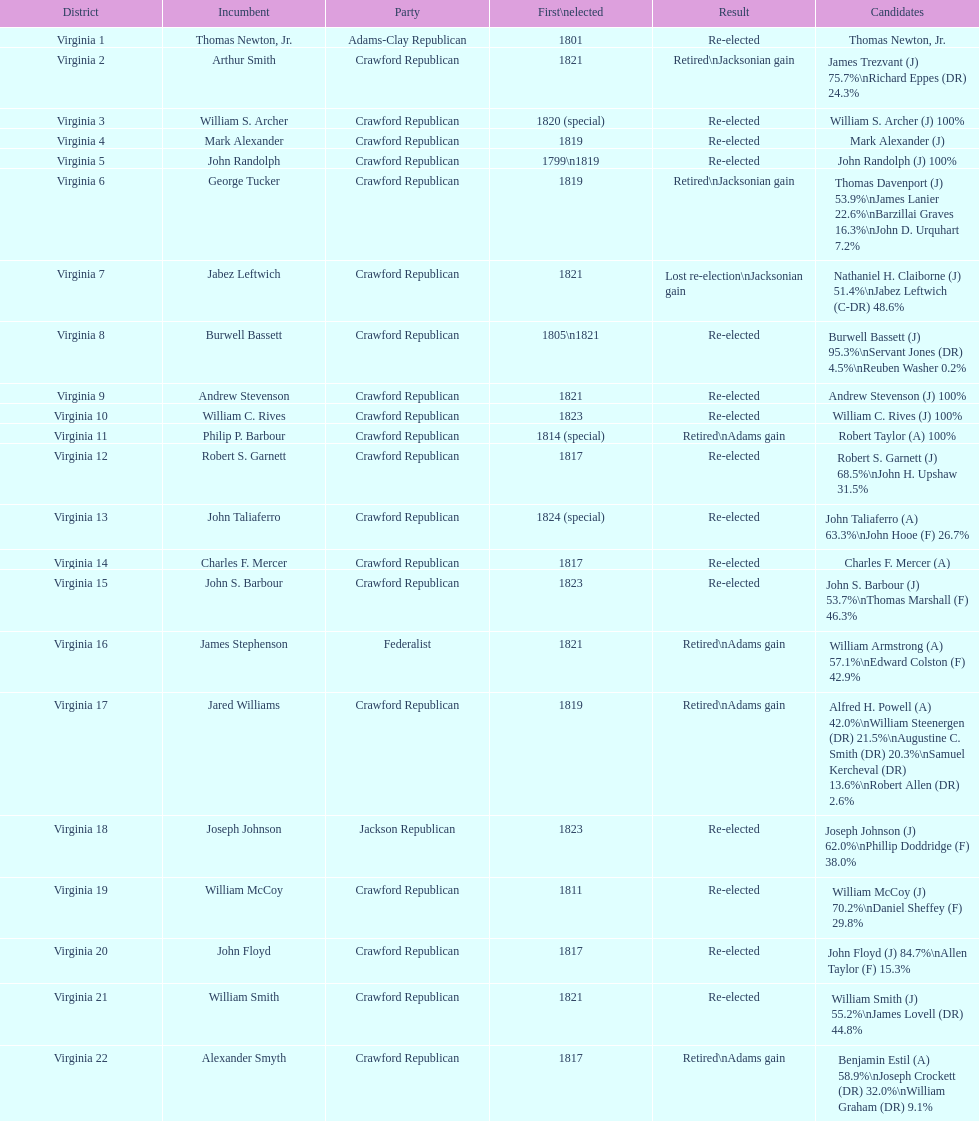Which individuals from the crawford republican party held office? Arthur Smith, William S. Archer, Mark Alexander, John Randolph, George Tucker, Jabez Leftwich, Burwell Bassett, Andrew Stevenson, William C. Rives, Philip P. Barbour, Robert S. Garnett, John Taliaferro, Charles F. Mercer, John S. Barbour, Jared Williams, William McCoy, John Floyd, William Smith, Alexander Smyth. Among them, who was first elected in 1821? Arthur Smith, Jabez Leftwich, Andrew Stevenson, William Smith. Are there any incumbents with the surname smith? Arthur Smith, William Smith. Which of these two failed to secure re-election? Arthur Smith. 